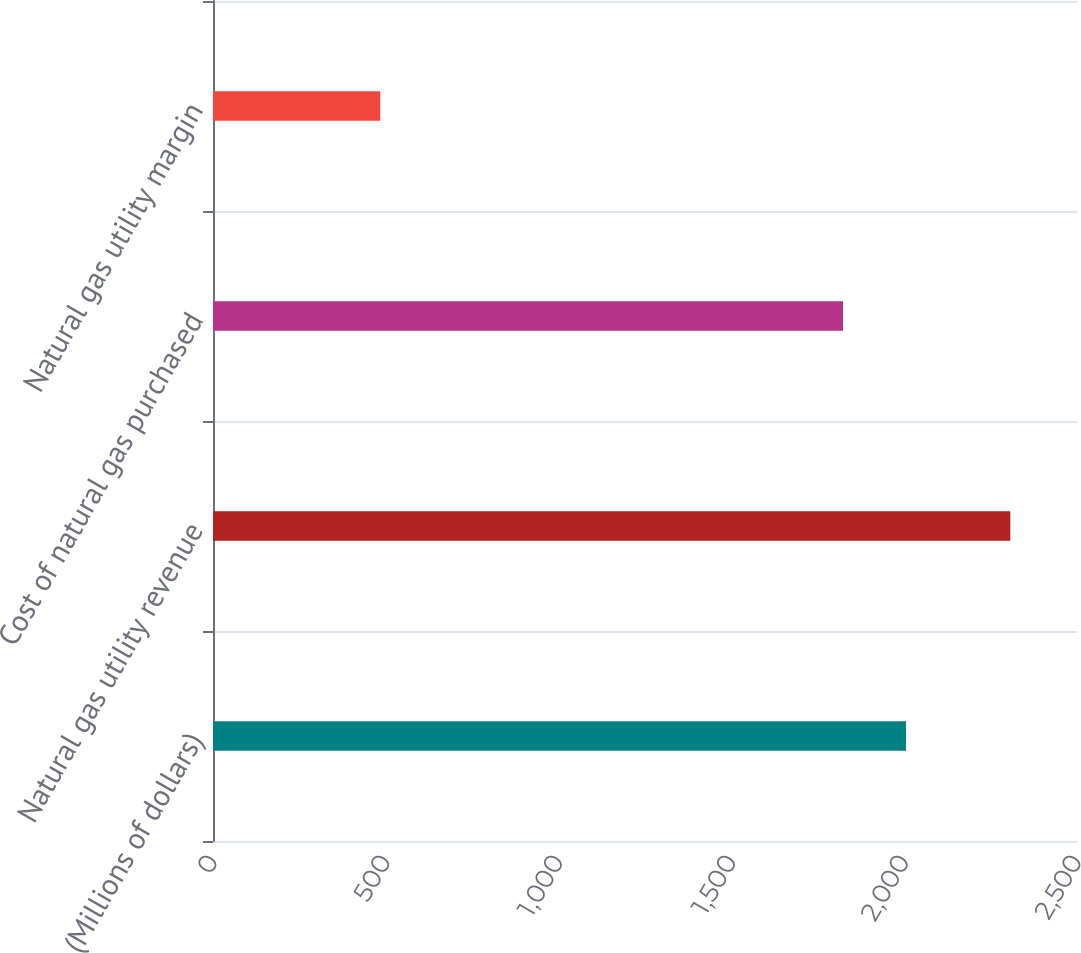Convert chart to OTSL. <chart><loc_0><loc_0><loc_500><loc_500><bar_chart><fcel>(Millions of dollars)<fcel>Natural gas utility revenue<fcel>Cost of natural gas purchased<fcel>Natural gas utility margin<nl><fcel>2005.3<fcel>2307<fcel>1823<fcel>484<nl></chart> 